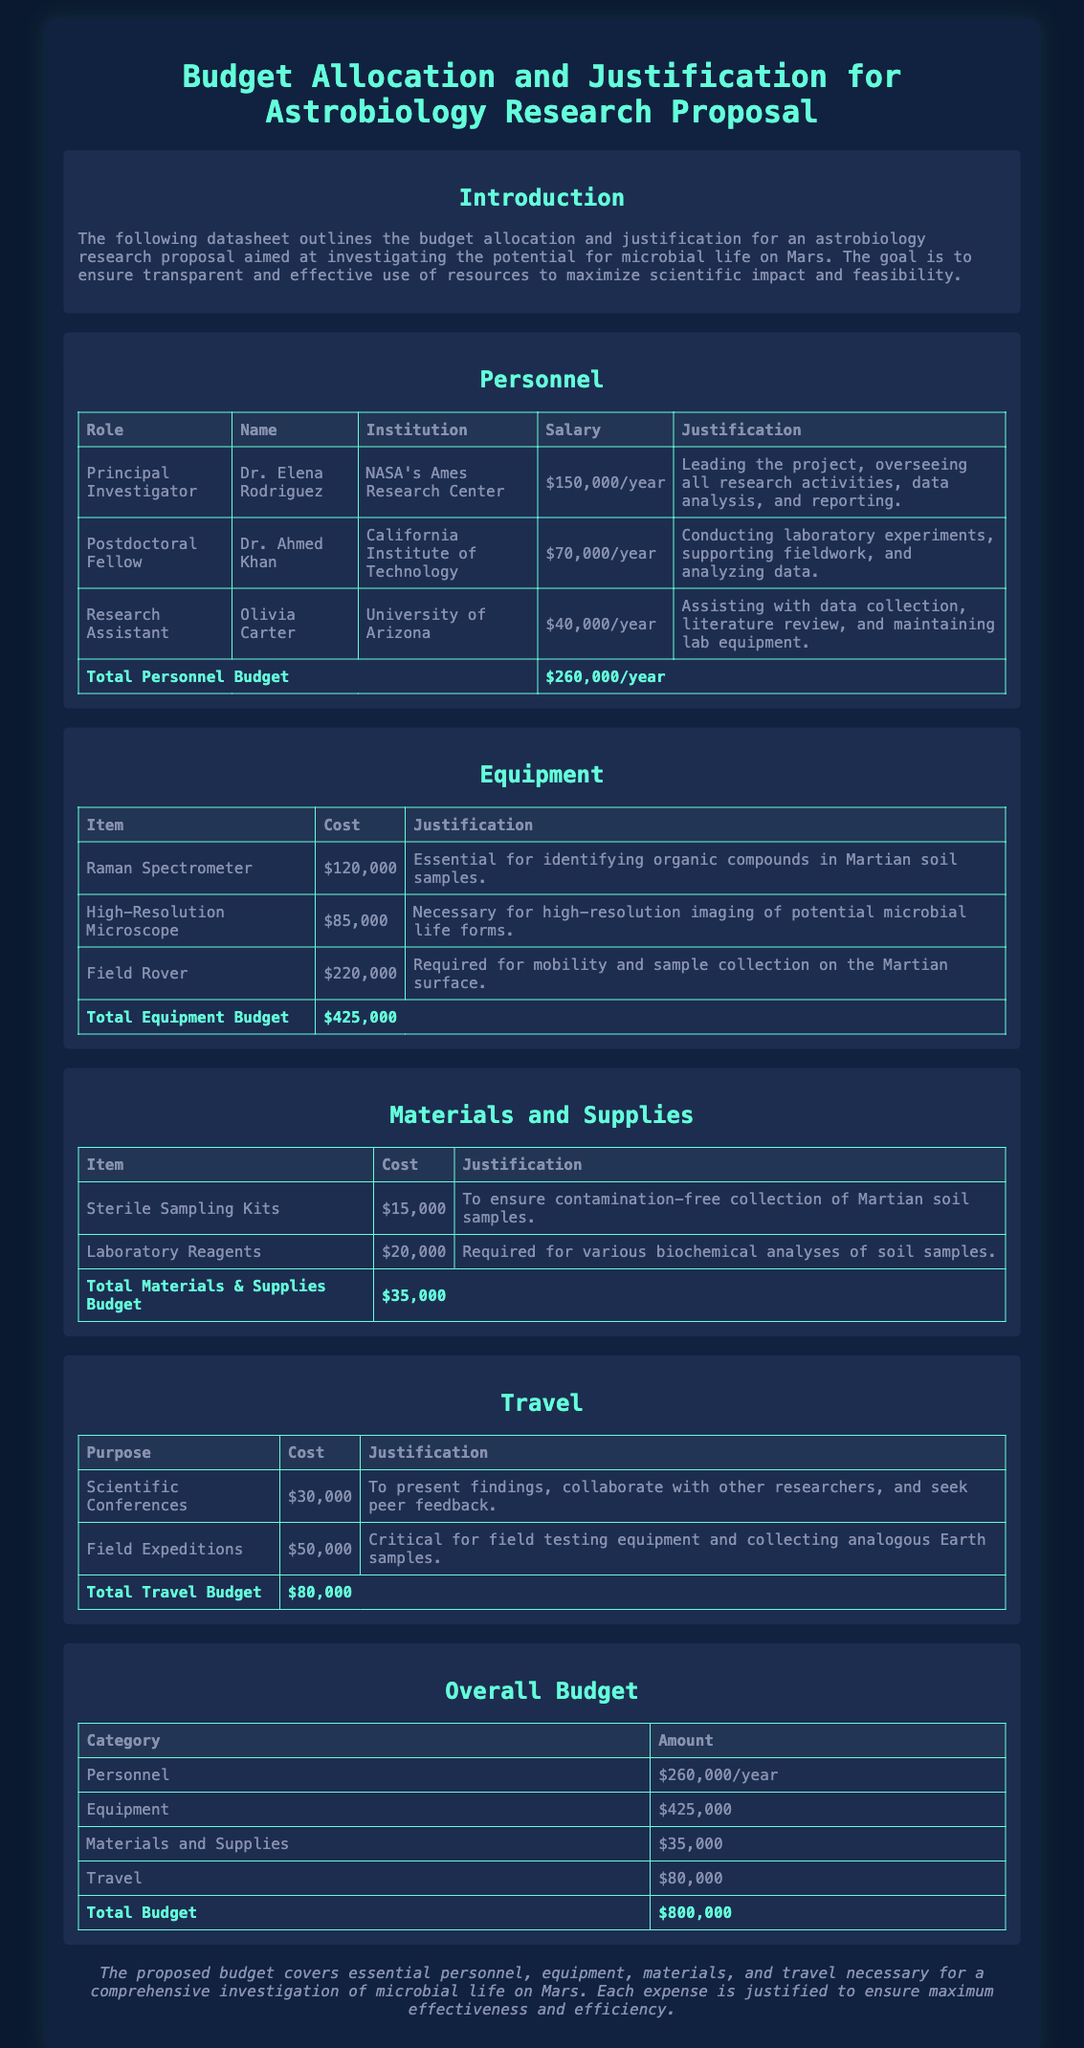What is the total Personnel Budget? The total Personnel Budget is the sum of all personnel salaries in the document, which is $150,000 + $70,000 + $40,000 = $260,000.
Answer: $260,000 Who is the Principal Investigator? The Principal Investigator is the lead researcher on the project, Dr. Elena Rodriguez, as stated in the Personnel section.
Answer: Dr. Elena Rodriguez What is the cost of the Field Rover? The cost of the Field Rover is specified in the Equipment section of the document.
Answer: $220,000 What is the total Equipment Budget? The total Equipment Budget is the sum of all equipment costs in the document, which is $120,000 + $85,000 + $220,000 = $425,000.
Answer: $425,000 What is the justification for the use of Sterile Sampling Kits? The justification for the Sterile Sampling Kits is mentioned in the Materials and Supplies section.
Answer: To ensure contamination-free collection of Martian soil samples What is the total Travel Budget? The total Travel Budget is the sum of the costs listed under the Travel section, which is $30,000 + $50,000 = $80,000.
Answer: $80,000 Which institution is Dr. Ahmed Khan affiliated with? Dr. Ahmed Khan's affiliation is listed in the Personnel section of the document.
Answer: California Institute of Technology What is the primary goal of this research proposal? The primary goal of the research proposal is mentioned in the Introduction section.
Answer: Investigating the potential for microbial life on Mars 